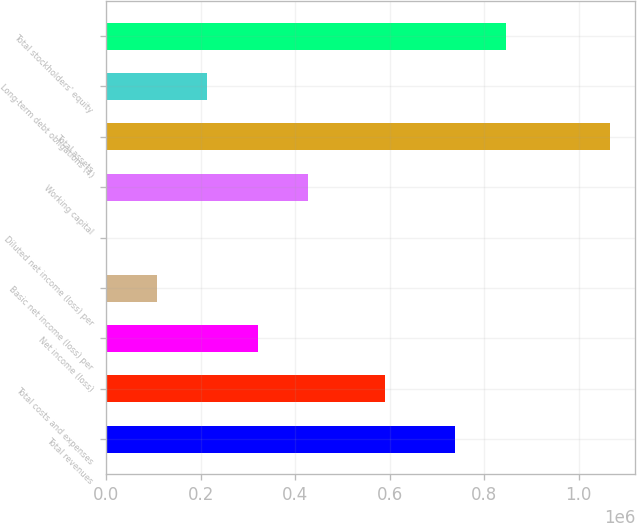Convert chart to OTSL. <chart><loc_0><loc_0><loc_500><loc_500><bar_chart><fcel>Total revenues<fcel>Total costs and expenses<fcel>Net income (loss)<fcel>Basic net income (loss) per<fcel>Diluted net income (loss) per<fcel>Working capital<fcel>Total assets<fcel>Long-term debt obligations (4)<fcel>Total stockholders' equity<nl><fcel>738368<fcel>590616<fcel>319905<fcel>106636<fcel>0.86<fcel>426540<fcel>1.06635e+06<fcel>213270<fcel>845003<nl></chart> 